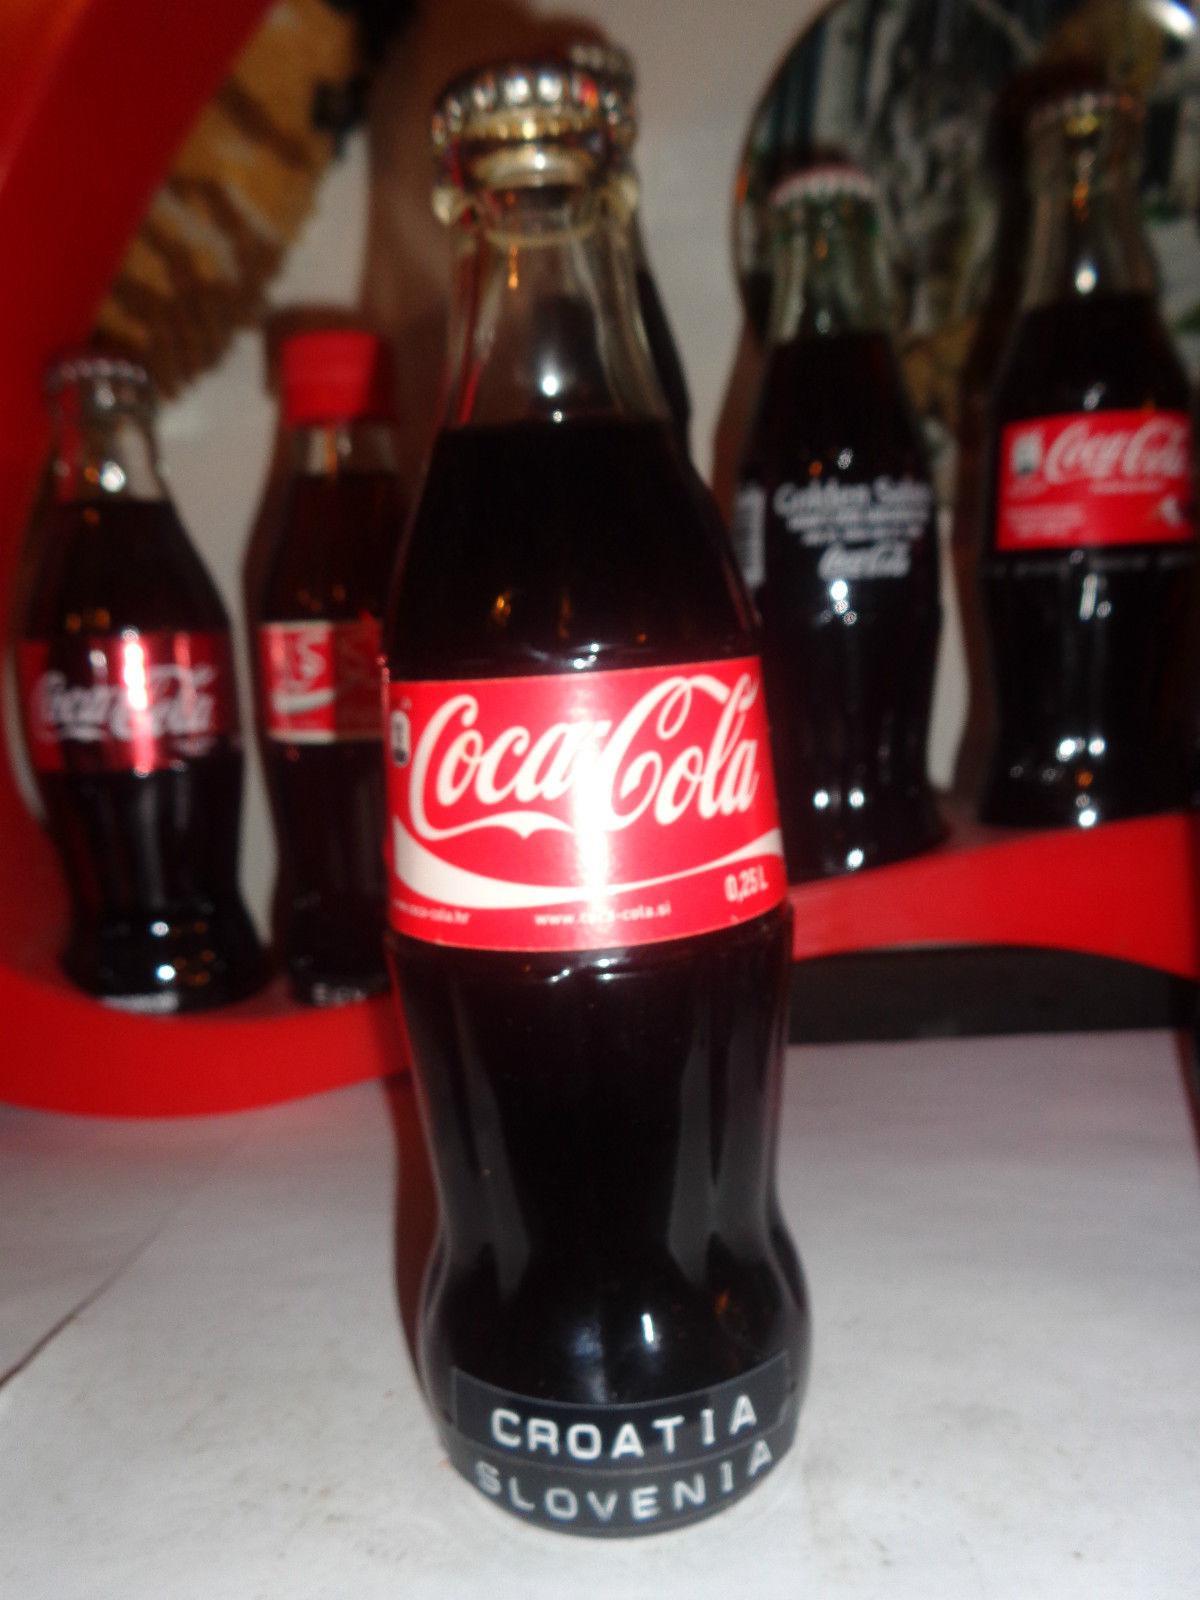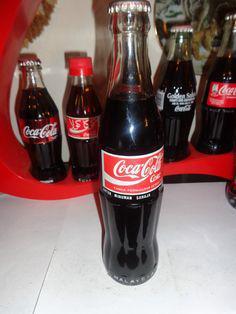The first image is the image on the left, the second image is the image on the right. For the images shown, is this caption "The front most bottle in each of the images has a similarly colored label." true? Answer yes or no. Yes. The first image is the image on the left, the second image is the image on the right. Analyze the images presented: Is the assertion "Two bottles are standing in front of all the others." valid? Answer yes or no. Yes. 